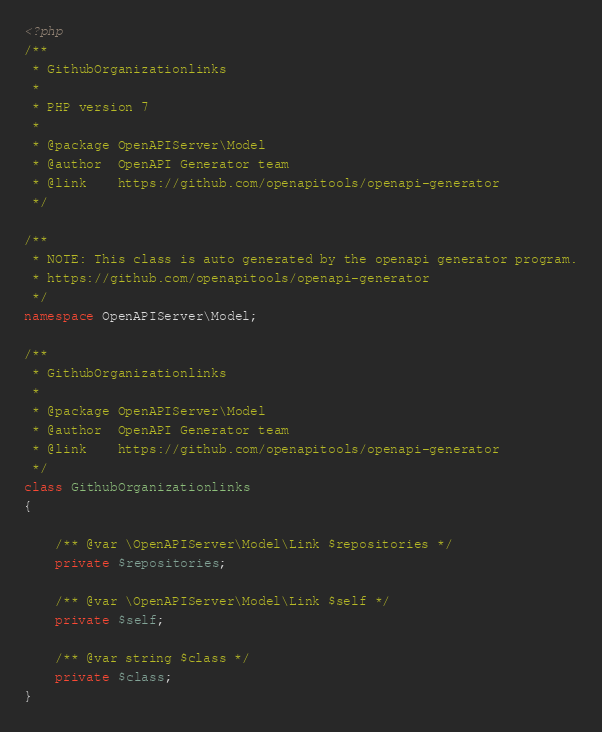Convert code to text. <code><loc_0><loc_0><loc_500><loc_500><_PHP_><?php
/**
 * GithubOrganizationlinks
 *
 * PHP version 7
 *
 * @package OpenAPIServer\Model
 * @author  OpenAPI Generator team
 * @link    https://github.com/openapitools/openapi-generator
 */

/**
 * NOTE: This class is auto generated by the openapi generator program.
 * https://github.com/openapitools/openapi-generator
 */
namespace OpenAPIServer\Model;

/**
 * GithubOrganizationlinks
 *
 * @package OpenAPIServer\Model
 * @author  OpenAPI Generator team
 * @link    https://github.com/openapitools/openapi-generator
 */
class GithubOrganizationlinks
{

    /** @var \OpenAPIServer\Model\Link $repositories */
    private $repositories;

    /** @var \OpenAPIServer\Model\Link $self */
    private $self;

    /** @var string $class */
    private $class;
}
</code> 